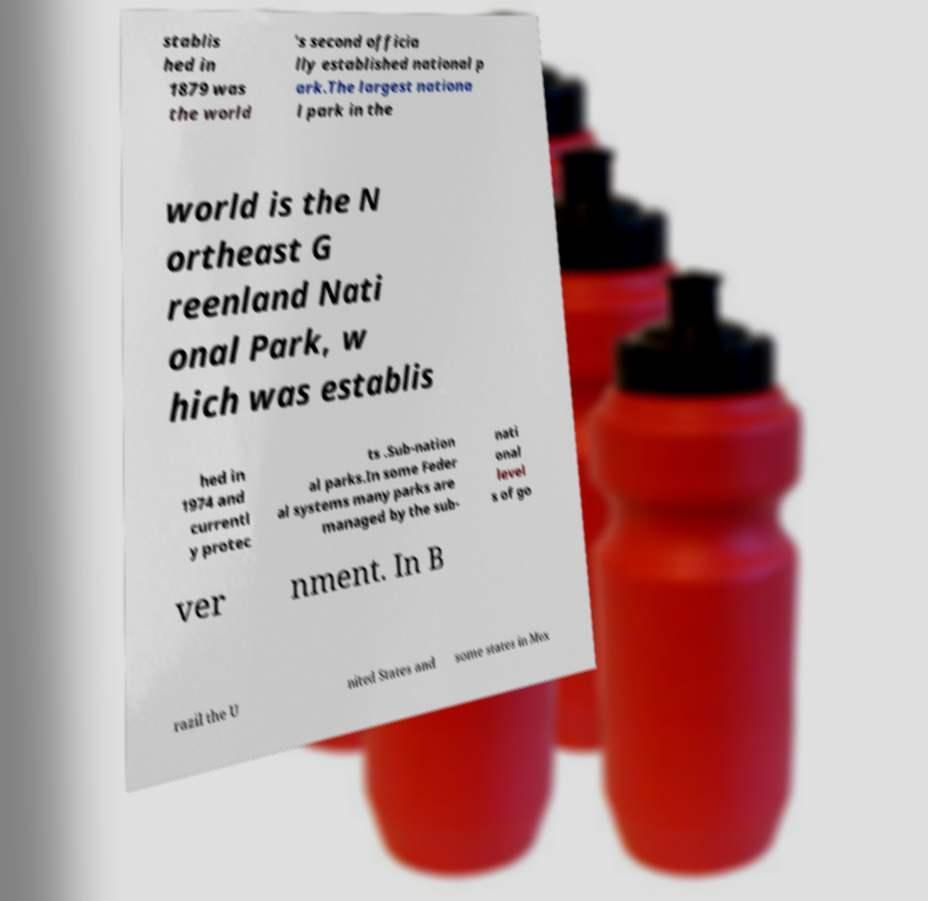For documentation purposes, I need the text within this image transcribed. Could you provide that? stablis hed in 1879 was the world 's second officia lly established national p ark.The largest nationa l park in the world is the N ortheast G reenland Nati onal Park, w hich was establis hed in 1974 and currentl y protec ts .Sub-nation al parks.In some Feder al systems many parks are managed by the sub- nati onal level s of go ver nment. In B razil the U nited States and some states in Mex 